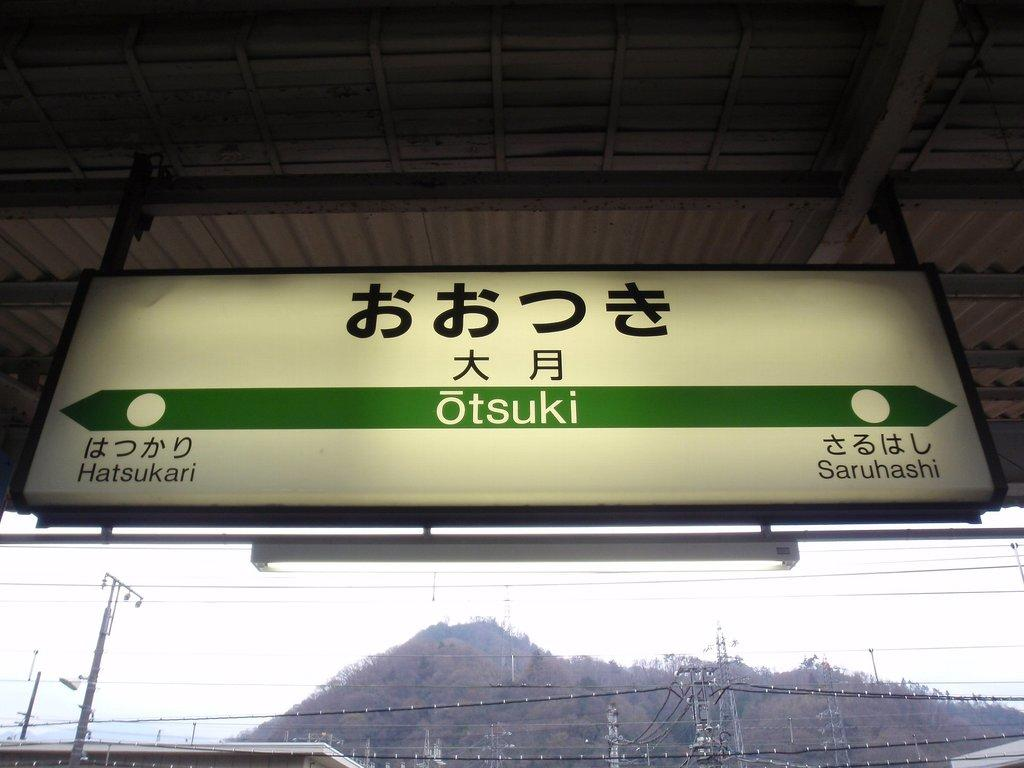<image>
Write a terse but informative summary of the picture. A hanging sign with Asian text on it that also says Otsuki. 